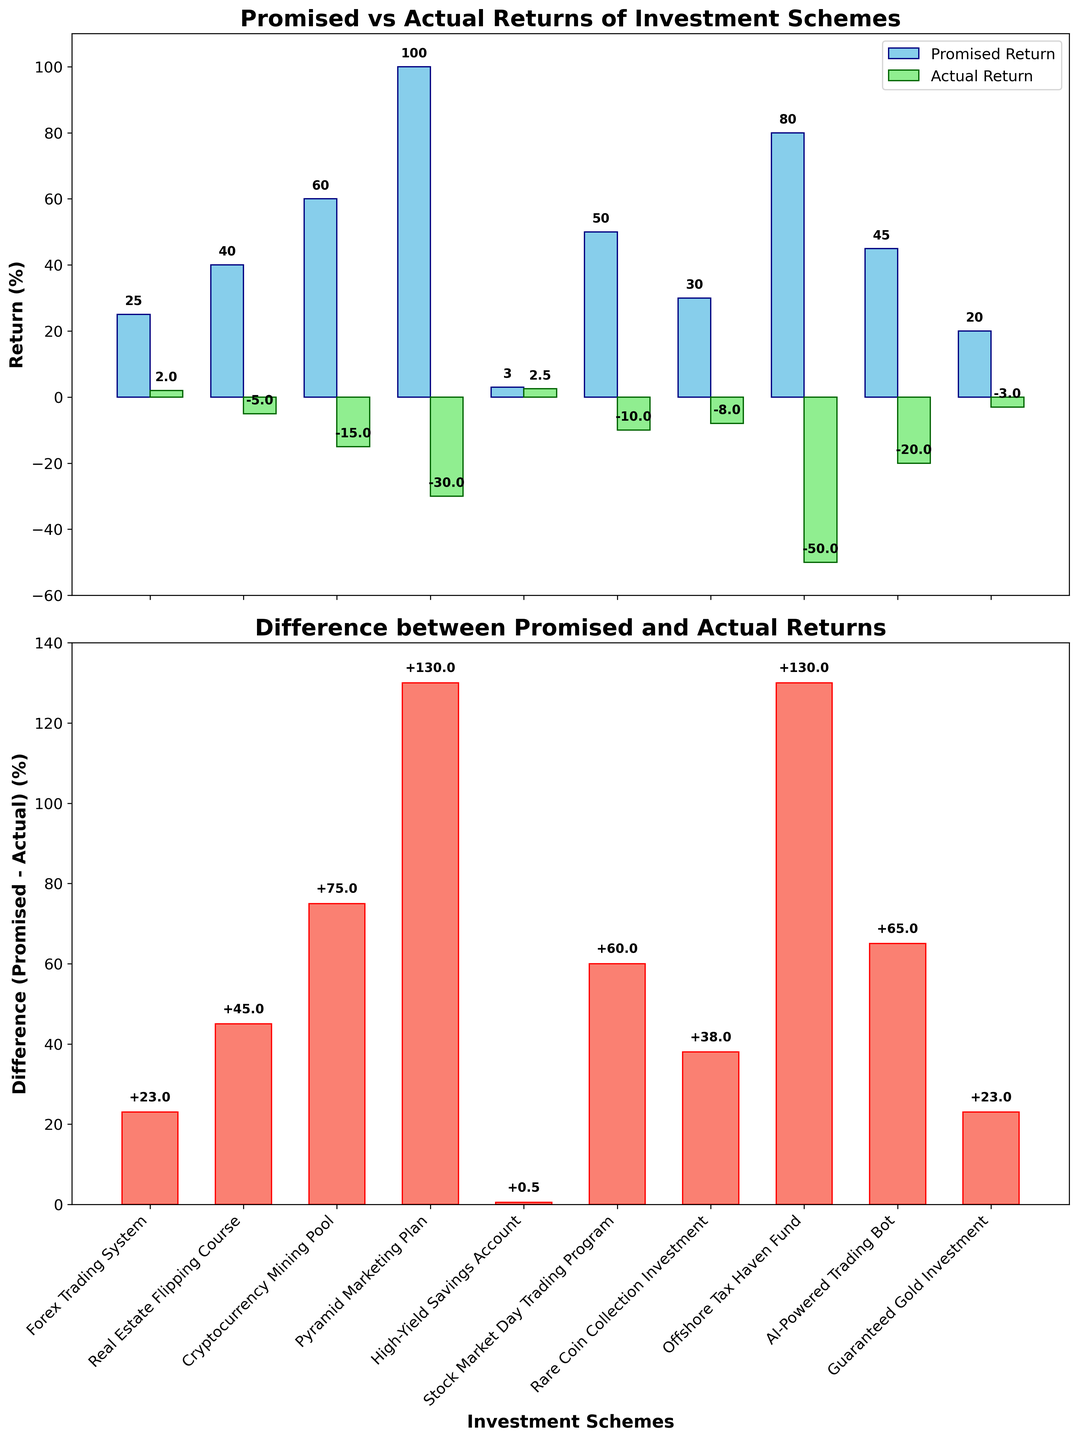What's the title of the first subplot? The title of the first subplot is located at the top of the first bar chart. It reads "Promised vs Actual Returns of Investment Schemes".
Answer: Promised vs Actual Returns of Investment Schemes What's the highest promised return shown in the first subplot? In the first subplot, the highest promised return is visible by the tallest bar reaching up to 100% for the "Pyramid Marketing Plan".
Answer: 100% Which investment scheme has the smallest difference between promised and actual returns? The second subplot displays the difference between promised and actual returns. The smallest bar indicates the "High-Yield Savings Account" with a very small difference of 0.5%.
Answer: High-Yield Savings Account What is the color of the bars representing actual returns in the first subplot? The bars representing actual returns in the first subplot are light green, as indicated in the legend.
Answer: Light green Compare the actual return of the Forex Trading System with the Offshorre Tax Haven Fund. Which one is higher? In the first subplot, the actual return of the Forex Trading System is represented by a bar that reaches 2%, while the Offshore Tax Haven Fund shows an actual return of -50%. The Forex Trading System has a higher actual return.
Answer: Forex Trading System What's the total combined promised return for the "Real Estate Flipping Course" and "Cryptocurrency Mining Pool"? From the first subplot, the promised returns for the "Real Estate Flipping Course" and "Cryptocurrency Mining Pool" are 40% and 60%, respectively. Adding them gives a total of 100%.
Answer: 100% Which investment scheme has the lowest actual return? The first subplot shows the lowest actual return by the shortest bar below 0%, which is -50% for the "Offshore Tax Haven Fund".
Answer: Offshore Tax Haven Fund How many investment schemes have a positive actual return? By examining the bars in the first subplot, only the "Forex Trading System" and "High-Yield Savings Account" have positive actual returns (above 0%).
Answer: 2 What is the difference between the promised and actual return for the "AI-Powered Trading Bot"? In the second subplot, the difference for the "AI-Powered Trading Bot" is shown as a bar reaching 65%.
Answer: 65% Which scheme has the largest negative difference between the promised and actual returns? From the second subplot, the "Offshore Tax Haven Fund" shows the largest difference, indicated by the highest bar reaching up to 130%.
Answer: Offshore Tax Haven Fund 